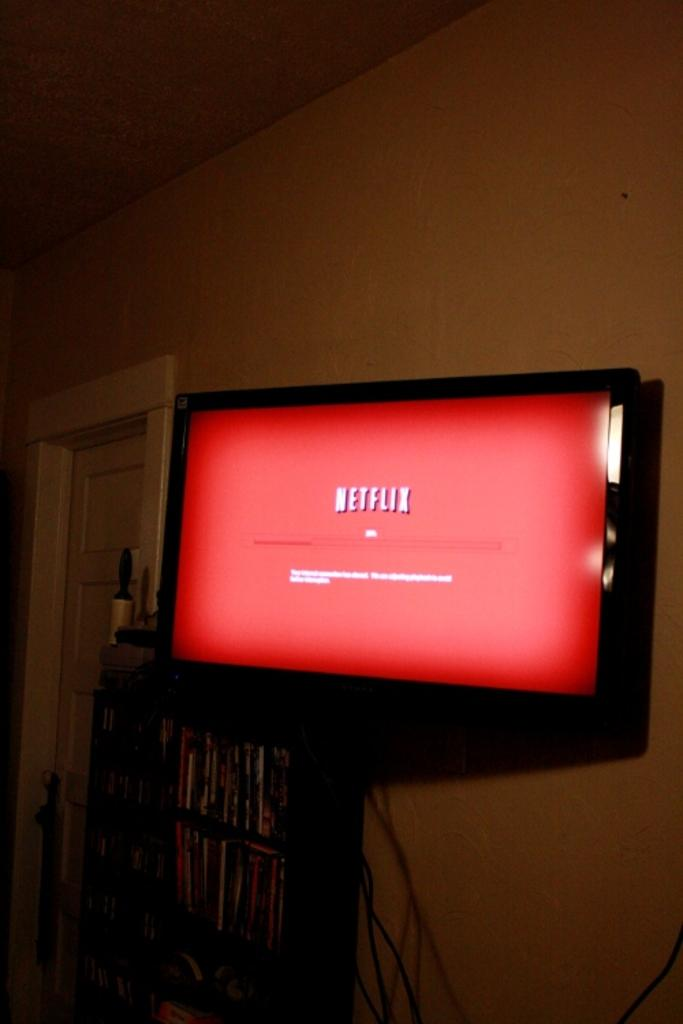<image>
Describe the image concisely. A TV mounted to the wall with the Netflix starting screen. 